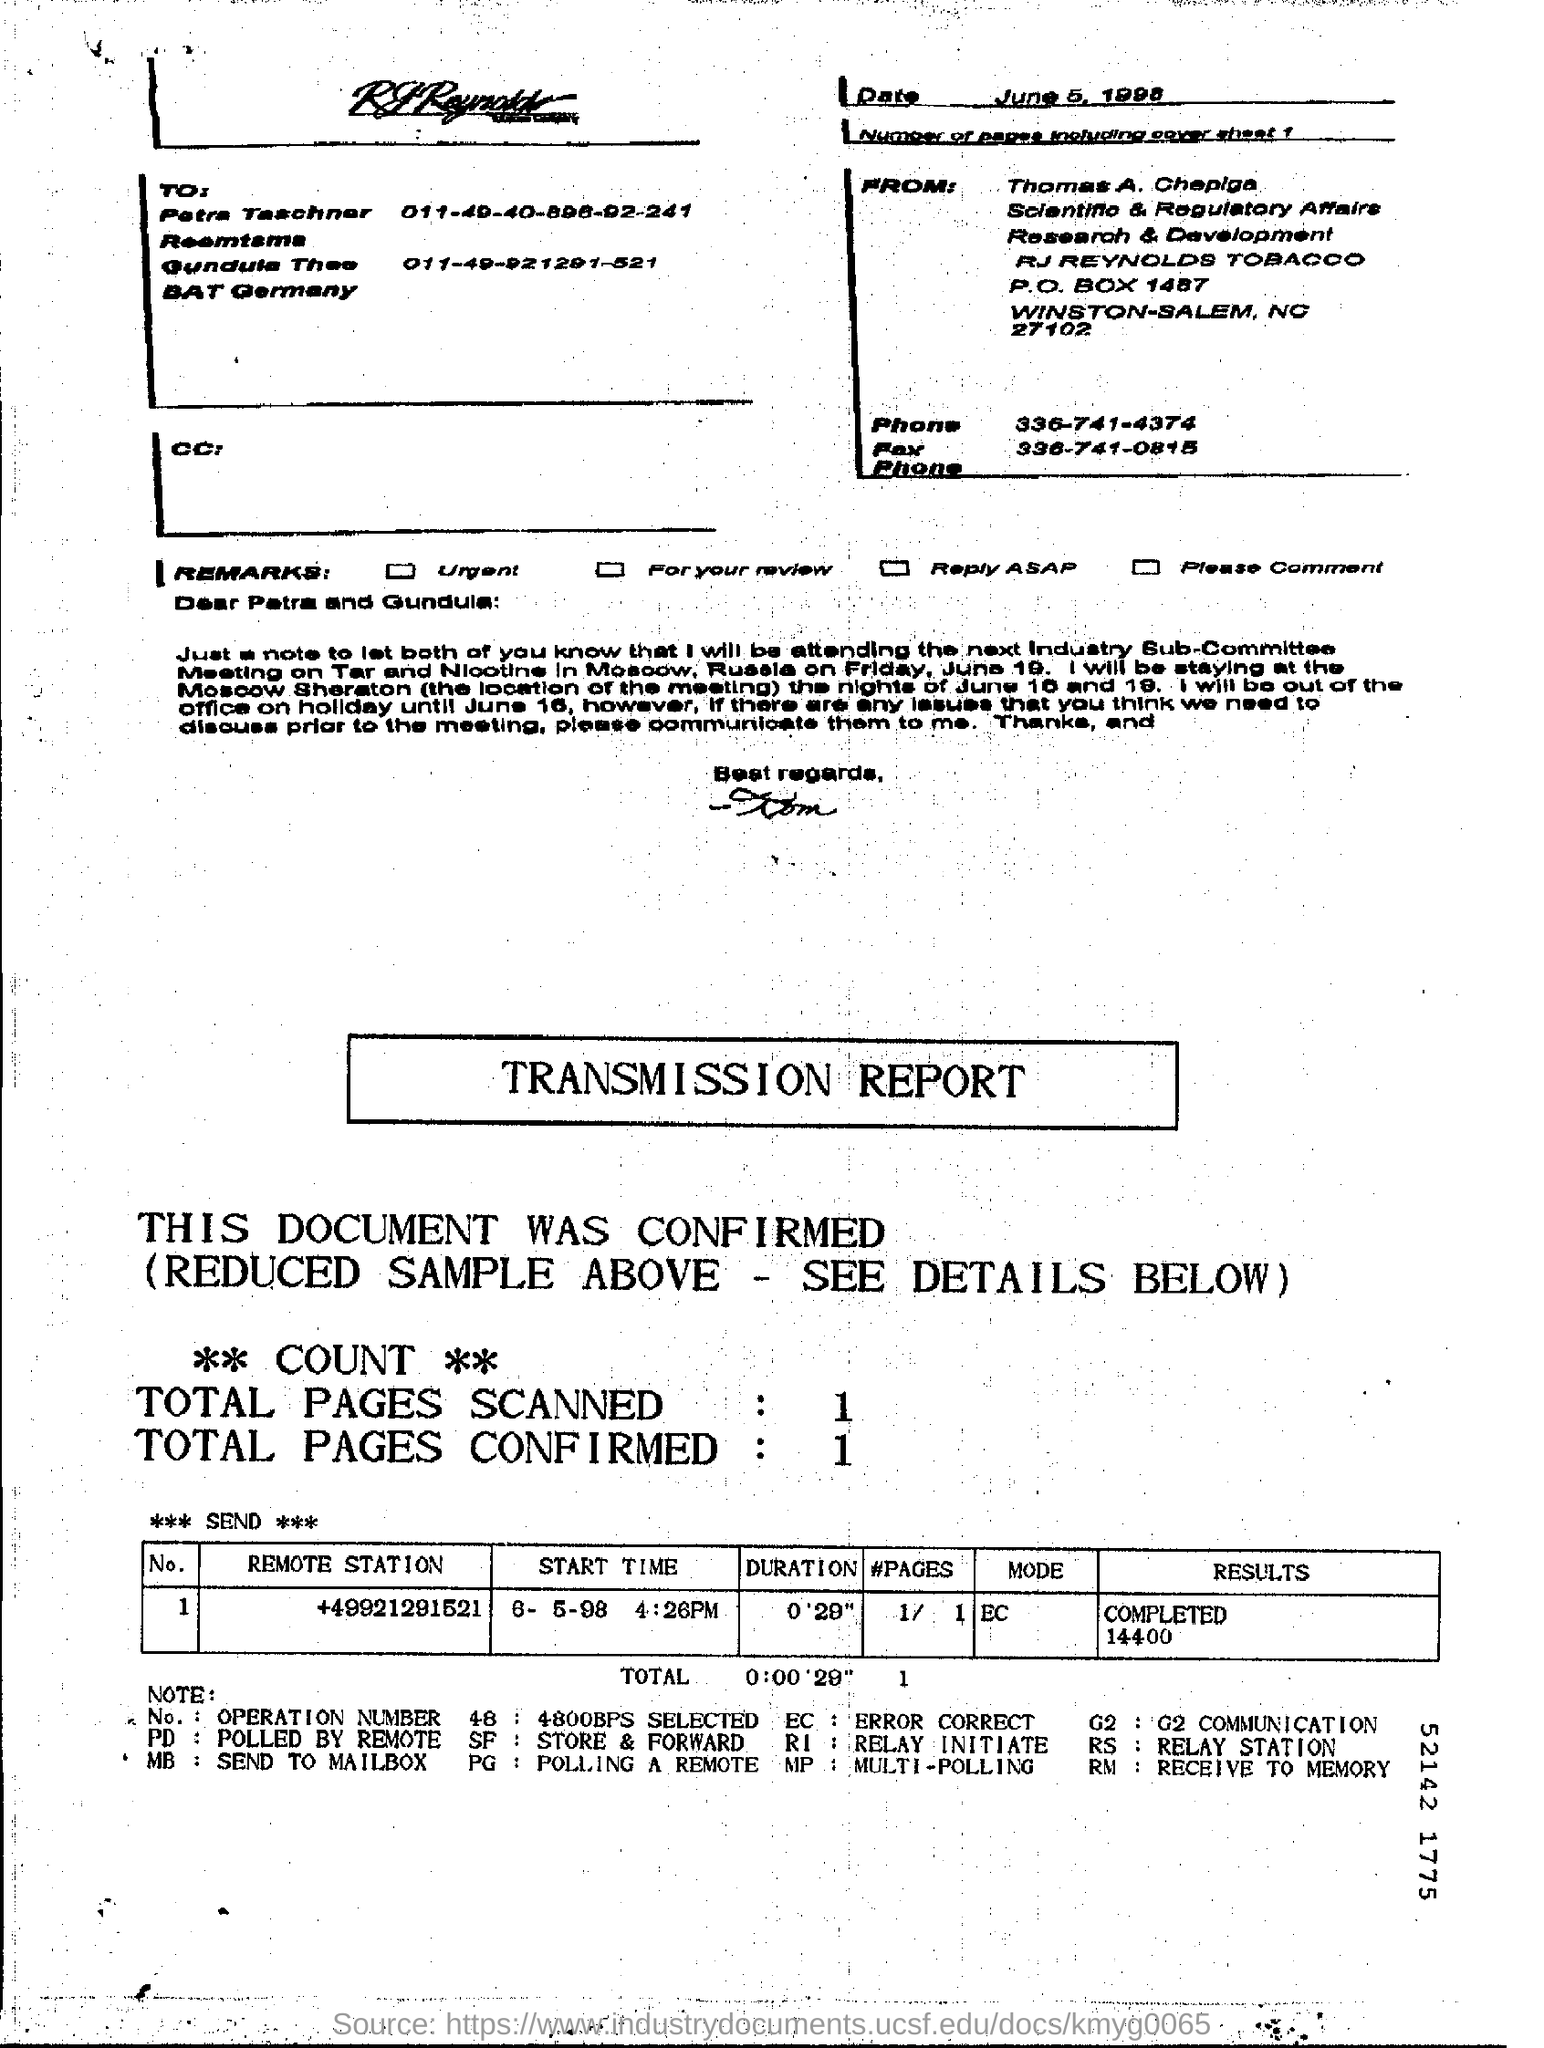Can you tell when this transmission report was generated and to whom it was addressed? The transmission report was generated on June 5, 1998. It is addressed to Petra Taschner and Gundula Thos from BAT Germany.  What was the purpose of this communication? The communication appears to be a transmission report indicating a successfully sent document, likely part of routine business communications regarding a research and development topic, as inferred from the sender's details associated with scientific and regulatory affairs. 